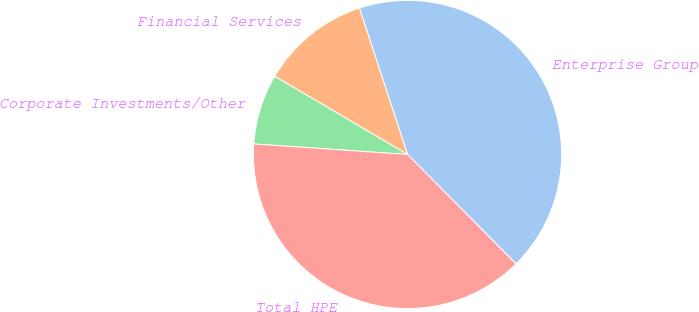Convert chart. <chart><loc_0><loc_0><loc_500><loc_500><pie_chart><fcel>Enterprise Group<fcel>Financial Services<fcel>Corporate Investments/Other<fcel>Total HPE<nl><fcel>42.62%<fcel>11.48%<fcel>7.38%<fcel>38.52%<nl></chart> 